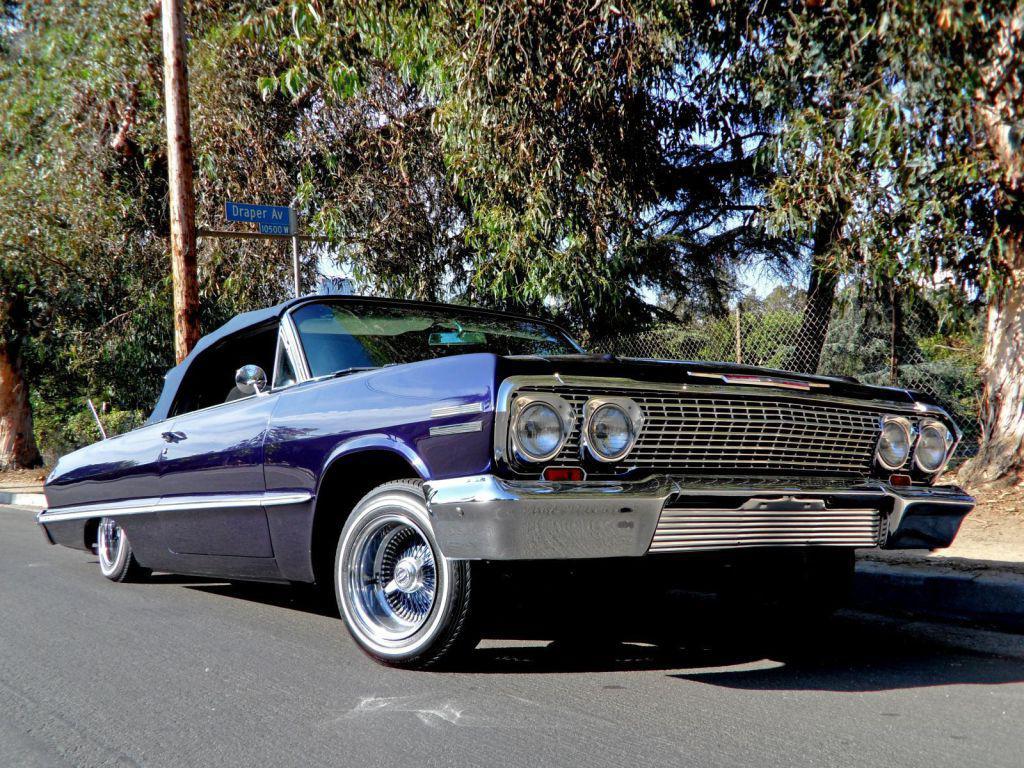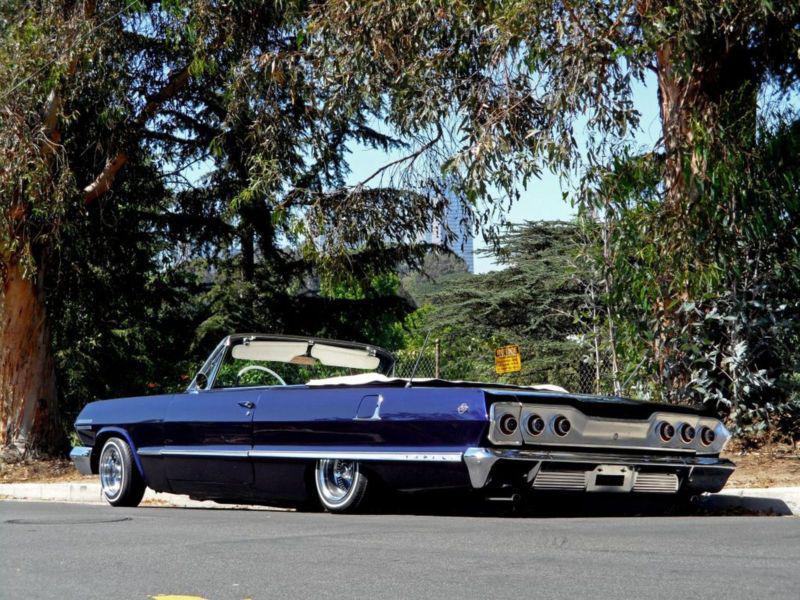The first image is the image on the left, the second image is the image on the right. For the images shown, is this caption "The car in the image on the right has their convertible top open." true? Answer yes or no. Yes. 